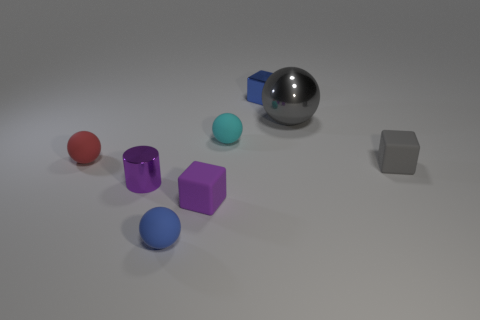Subtract all tiny spheres. How many spheres are left? 1 Subtract all red spheres. How many spheres are left? 3 Add 1 tiny blue metal objects. How many objects exist? 9 Subtract all yellow balls. Subtract all yellow blocks. How many balls are left? 4 Subtract all cylinders. How many objects are left? 7 Add 5 small cyan rubber spheres. How many small cyan rubber spheres are left? 6 Add 5 gray metal objects. How many gray metal objects exist? 6 Subtract 0 brown spheres. How many objects are left? 8 Subtract all cyan balls. Subtract all small yellow metal balls. How many objects are left? 7 